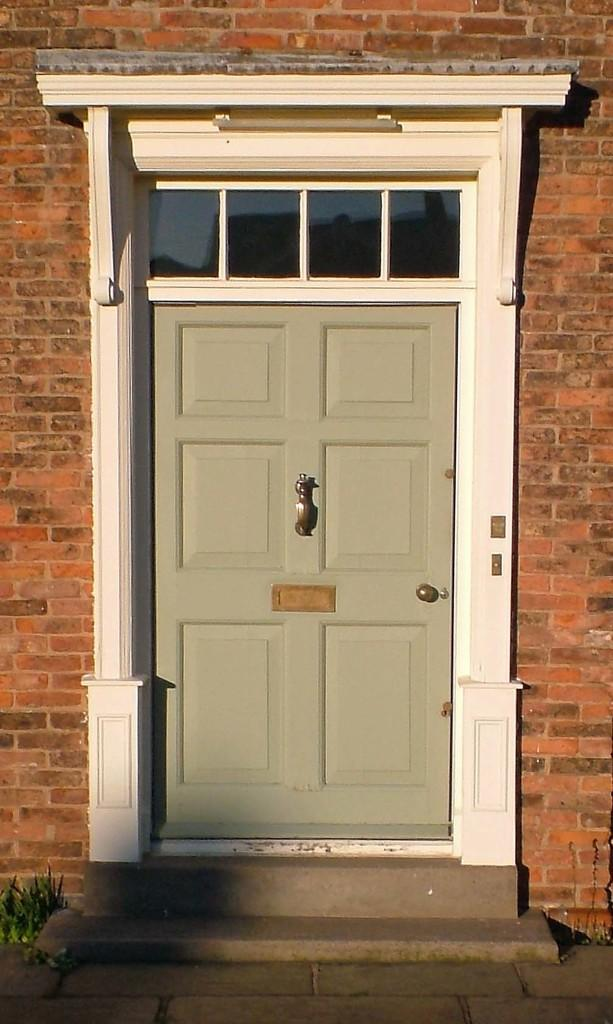What structure is present in the image? There is a door in the image. What type of surface is visible in the image? There is ground visible in the image. What type of vegetation is present in the image? There is a plant in the image. What type of material is used for the wall in the image? There is a brick wall in the image. What type of ice can be seen melting on the door in the image? There is no ice present on the door in the image. What type of society is depicted in the image? The image does not depict any society; it features a door, ground, a plant, and a brick wall. 